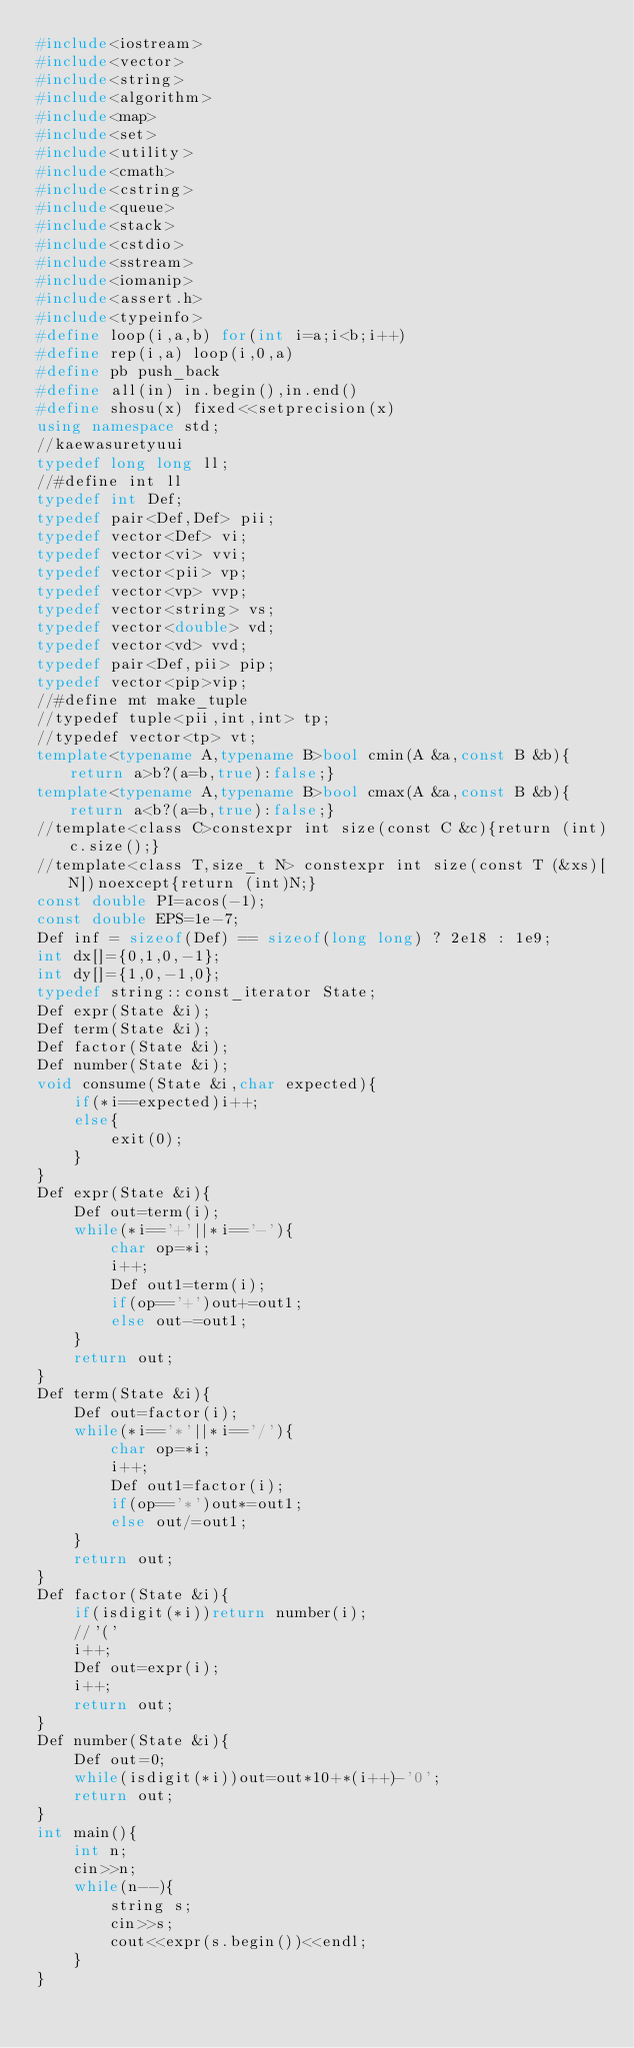<code> <loc_0><loc_0><loc_500><loc_500><_C++_>#include<iostream>
#include<vector>
#include<string>
#include<algorithm>	
#include<map>
#include<set>
#include<utility>
#include<cmath>
#include<cstring>
#include<queue>
#include<stack>
#include<cstdio>
#include<sstream>
#include<iomanip>
#include<assert.h>
#include<typeinfo>
#define loop(i,a,b) for(int i=a;i<b;i++) 
#define rep(i,a) loop(i,0,a)
#define pb push_back
#define all(in) in.begin(),in.end()
#define shosu(x) fixed<<setprecision(x)
using namespace std;
//kaewasuretyuui
typedef long long ll;
//#define int ll
typedef int Def;
typedef pair<Def,Def> pii;
typedef vector<Def> vi;
typedef vector<vi> vvi;
typedef vector<pii> vp;
typedef vector<vp> vvp;
typedef vector<string> vs;
typedef vector<double> vd;
typedef vector<vd> vvd;
typedef pair<Def,pii> pip;
typedef vector<pip>vip;
//#define mt make_tuple
//typedef tuple<pii,int,int> tp;
//typedef vector<tp> vt;
template<typename A,typename B>bool cmin(A &a,const B &b){return a>b?(a=b,true):false;}
template<typename A,typename B>bool cmax(A &a,const B &b){return a<b?(a=b,true):false;}
//template<class C>constexpr int size(const C &c){return (int)c.size();}
//template<class T,size_t N> constexpr int size(const T (&xs)[N])noexcept{return (int)N;}
const double PI=acos(-1);
const double EPS=1e-7;
Def inf = sizeof(Def) == sizeof(long long) ? 2e18 : 1e9;
int dx[]={0,1,0,-1};
int dy[]={1,0,-1,0};
typedef string::const_iterator State;
Def expr(State &i);
Def term(State &i);
Def factor(State &i);
Def number(State &i);
void consume(State &i,char expected){
	if(*i==expected)i++;
	else{
		exit(0);
	}
}
Def expr(State &i){
	Def out=term(i);
	while(*i=='+'||*i=='-'){
		char op=*i;
		i++;
		Def out1=term(i);
		if(op=='+')out+=out1;
		else out-=out1;
	}
	return out;
}
Def term(State &i){
	Def out=factor(i);
	while(*i=='*'||*i=='/'){
		char op=*i;
		i++;
		Def out1=factor(i);
		if(op=='*')out*=out1;
		else out/=out1;
	}
	return out;
}
Def factor(State &i){
	if(isdigit(*i))return number(i);
	//'('
	i++;
	Def out=expr(i);
	i++;
	return out;
}
Def number(State &i){
	Def out=0;
	while(isdigit(*i))out=out*10+*(i++)-'0';
	return out;
}
int main(){
	int n;
	cin>>n;
	while(n--){
		string s;
		cin>>s;
		cout<<expr(s.begin())<<endl;
	}
}</code> 